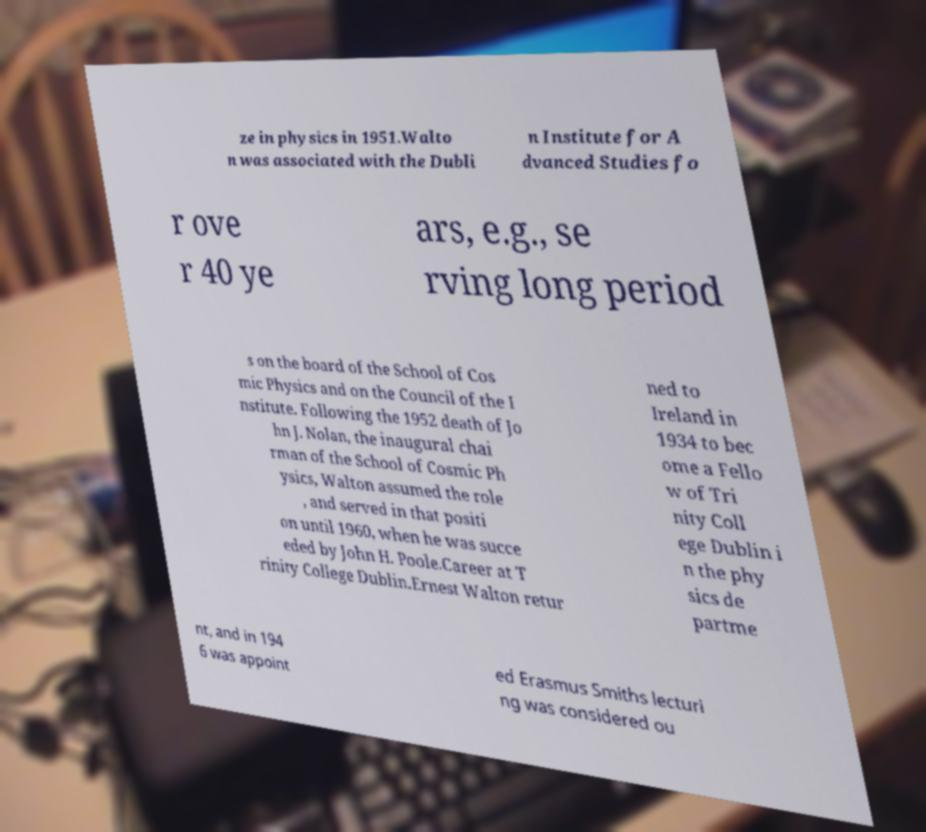What messages or text are displayed in this image? I need them in a readable, typed format. ze in physics in 1951.Walto n was associated with the Dubli n Institute for A dvanced Studies fo r ove r 40 ye ars, e.g., se rving long period s on the board of the School of Cos mic Physics and on the Council of the I nstitute. Following the 1952 death of Jo hn J. Nolan, the inaugural chai rman of the School of Cosmic Ph ysics, Walton assumed the role , and served in that positi on until 1960, when he was succe eded by John H. Poole.Career at T rinity College Dublin.Ernest Walton retur ned to Ireland in 1934 to bec ome a Fello w of Tri nity Coll ege Dublin i n the phy sics de partme nt, and in 194 6 was appoint ed Erasmus Smiths lecturi ng was considered ou 